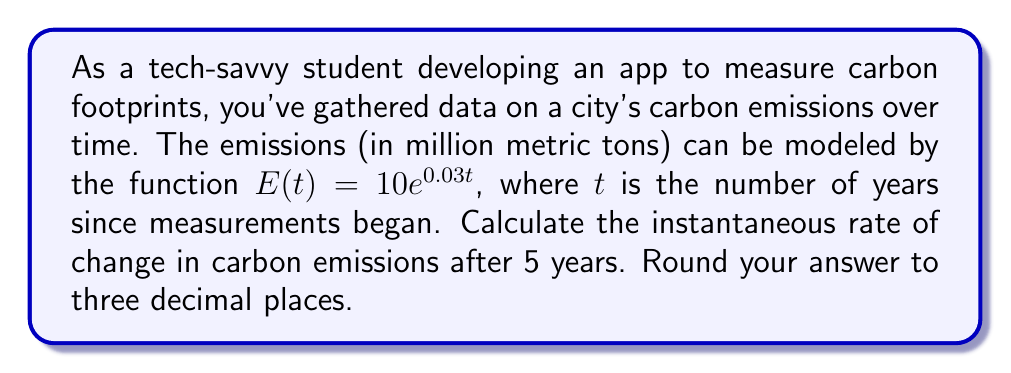Provide a solution to this math problem. To solve this problem, we need to find the derivative of the given function and evaluate it at $t = 5$. Here's the step-by-step process:

1) The given function is $E(t) = 10e^{0.03t}$

2) To find the rate of change, we need to differentiate $E(t)$ with respect to $t$:

   $$\frac{d}{dt}E(t) = \frac{d}{dt}(10e^{0.03t})$$

3) Using the chain rule and the fact that the derivative of $e^x$ is $e^x$, we get:

   $$E'(t) = 10 \cdot 0.03 \cdot e^{0.03t}$$

4) Simplify:

   $$E'(t) = 0.3e^{0.03t}$$

5) This function $E'(t)$ gives us the instantaneous rate of change at any time $t$. To find the rate after 5 years, we evaluate $E'(5)$:

   $$E'(5) = 0.3e^{0.03 \cdot 5}$$

6) Calculate:

   $$E'(5) = 0.3e^{0.15} \approx 0.348$$

7) Rounding to three decimal places, we get 0.348.

This means that after 5 years, the carbon emissions are increasing at a rate of approximately 0.348 million metric tons per year.
Answer: 0.348 million metric tons per year 